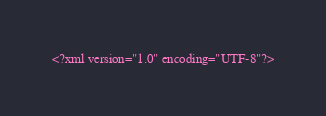Convert code to text. <code><loc_0><loc_0><loc_500><loc_500><_XML_><?xml version="1.0" encoding="UTF-8"?></code> 